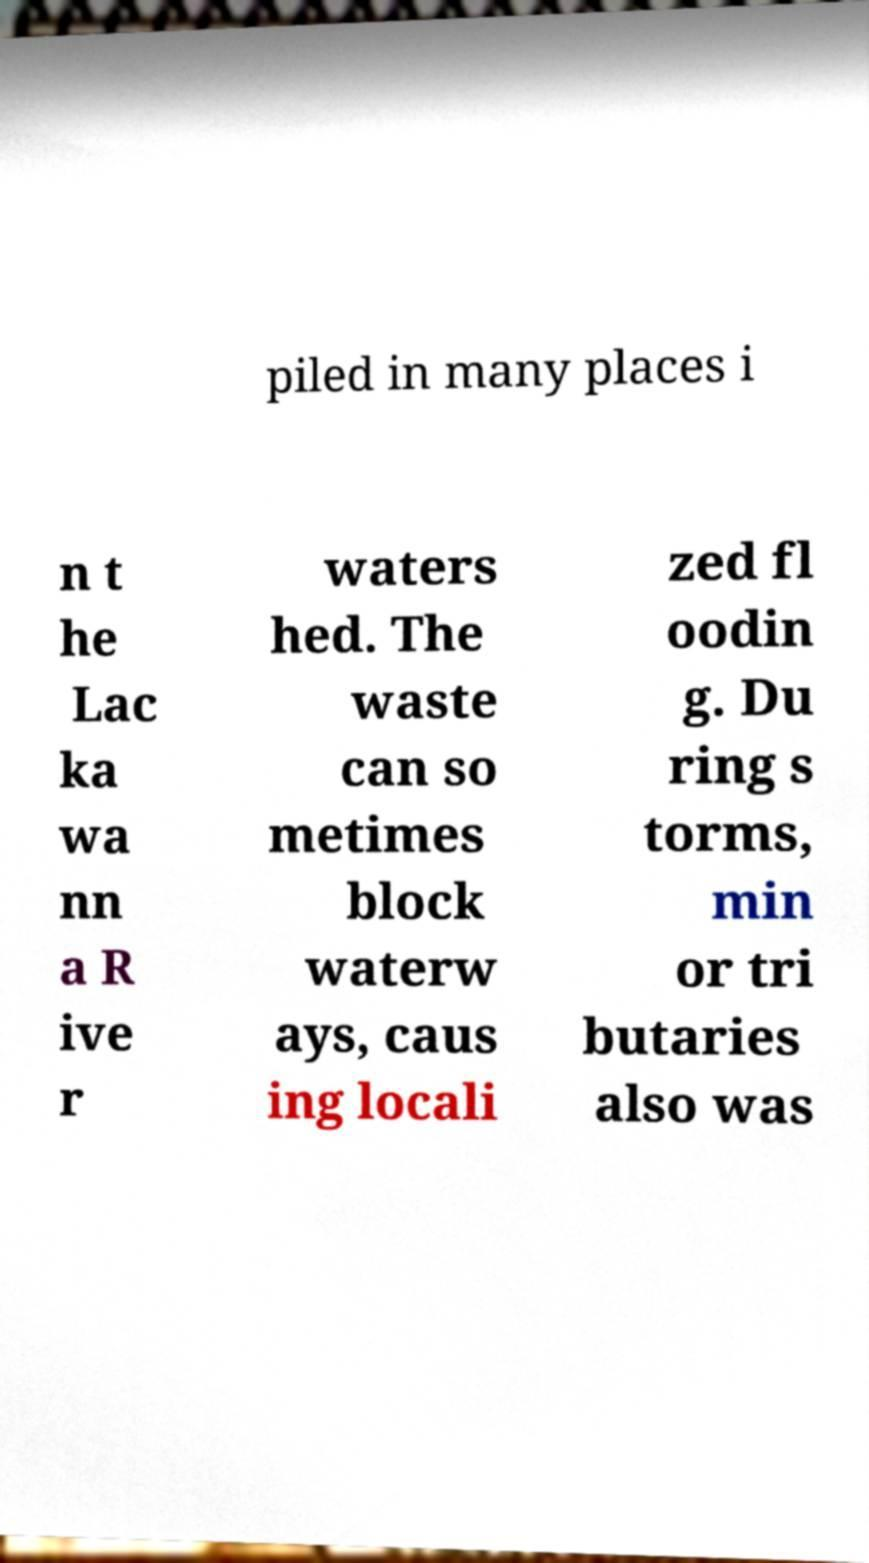Please identify and transcribe the text found in this image. piled in many places i n t he Lac ka wa nn a R ive r waters hed. The waste can so metimes block waterw ays, caus ing locali zed fl oodin g. Du ring s torms, min or tri butaries also was 